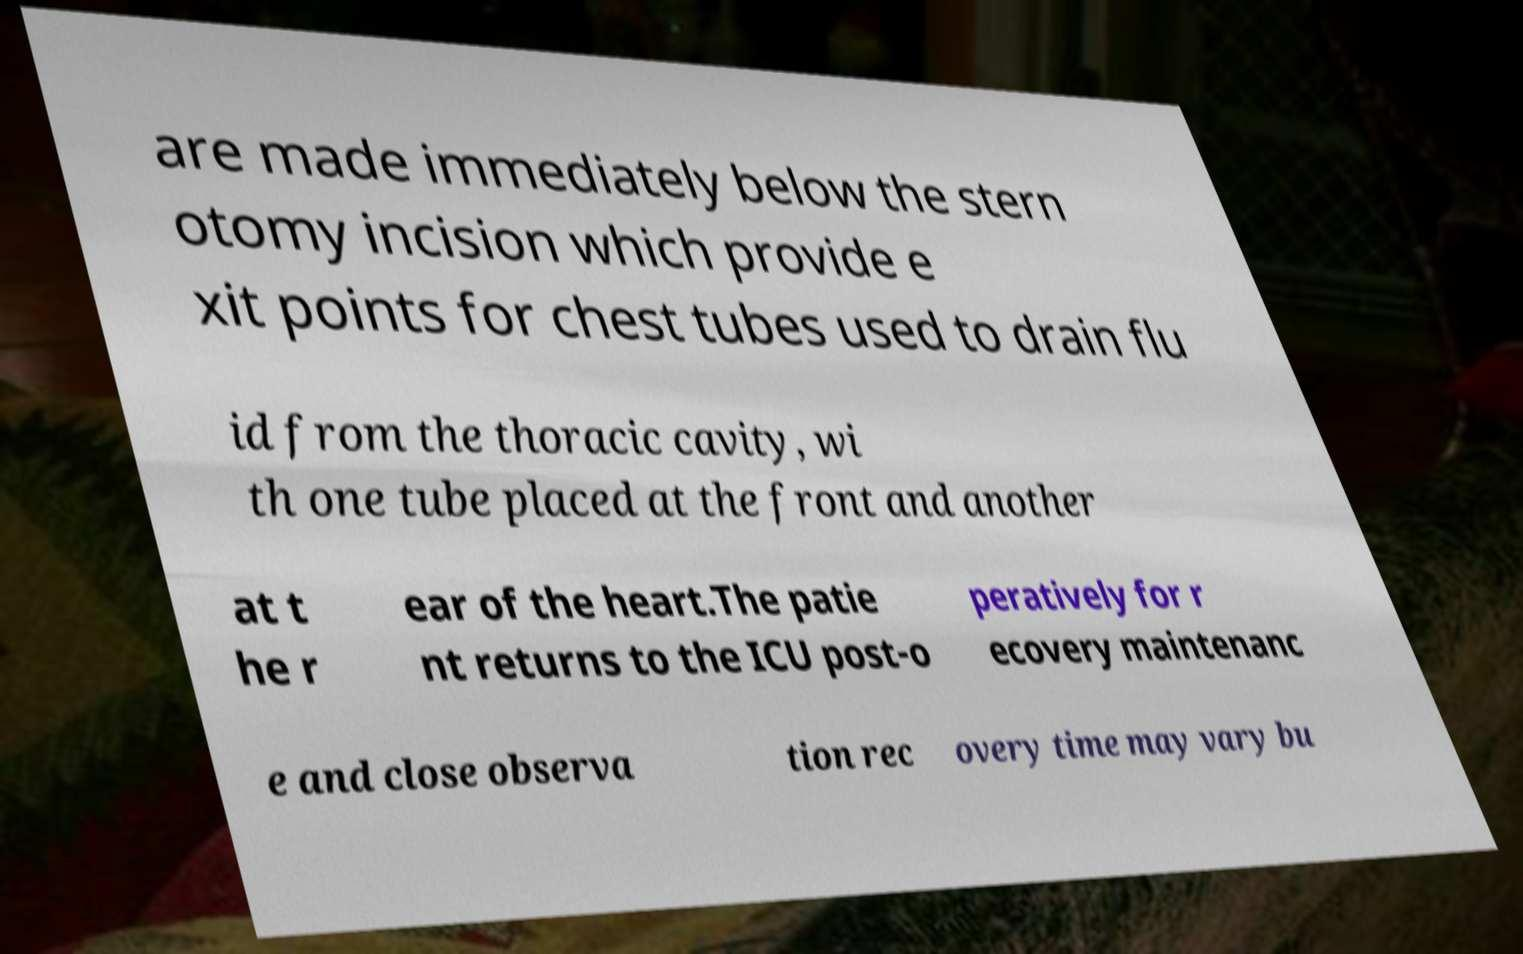Could you assist in decoding the text presented in this image and type it out clearly? are made immediately below the stern otomy incision which provide e xit points for chest tubes used to drain flu id from the thoracic cavity, wi th one tube placed at the front and another at t he r ear of the heart.The patie nt returns to the ICU post-o peratively for r ecovery maintenanc e and close observa tion rec overy time may vary bu 